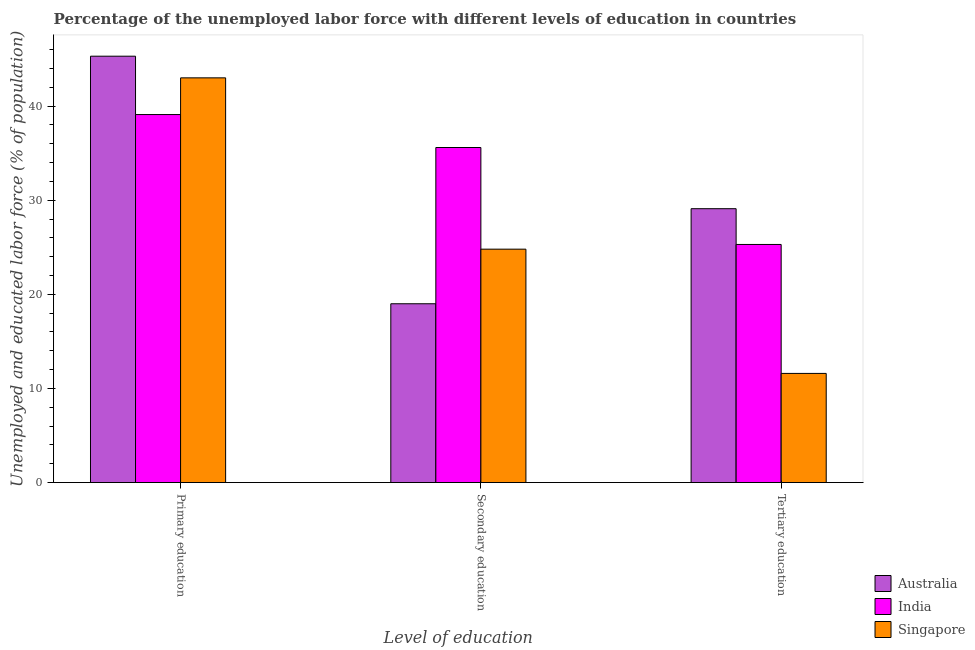How many groups of bars are there?
Provide a short and direct response. 3. Are the number of bars on each tick of the X-axis equal?
Ensure brevity in your answer.  Yes. How many bars are there on the 2nd tick from the right?
Provide a short and direct response. 3. What is the label of the 3rd group of bars from the left?
Provide a short and direct response. Tertiary education. What is the percentage of labor force who received tertiary education in Australia?
Your response must be concise. 29.1. Across all countries, what is the maximum percentage of labor force who received secondary education?
Ensure brevity in your answer.  35.6. Across all countries, what is the minimum percentage of labor force who received secondary education?
Your answer should be very brief. 19. What is the total percentage of labor force who received secondary education in the graph?
Your response must be concise. 79.4. What is the difference between the percentage of labor force who received primary education in Singapore and that in India?
Provide a short and direct response. 3.9. What is the difference between the percentage of labor force who received secondary education in Australia and the percentage of labor force who received primary education in Singapore?
Give a very brief answer. -24. What is the average percentage of labor force who received secondary education per country?
Give a very brief answer. 26.47. What is the difference between the percentage of labor force who received tertiary education and percentage of labor force who received secondary education in India?
Your response must be concise. -10.3. In how many countries, is the percentage of labor force who received secondary education greater than 26 %?
Offer a very short reply. 1. What is the ratio of the percentage of labor force who received tertiary education in Australia to that in India?
Your answer should be very brief. 1.15. What is the difference between the highest and the second highest percentage of labor force who received tertiary education?
Your response must be concise. 3.8. What is the difference between the highest and the lowest percentage of labor force who received secondary education?
Offer a very short reply. 16.6. What does the 1st bar from the left in Secondary education represents?
Ensure brevity in your answer.  Australia. What is the difference between two consecutive major ticks on the Y-axis?
Your response must be concise. 10. Are the values on the major ticks of Y-axis written in scientific E-notation?
Provide a succinct answer. No. Does the graph contain grids?
Your answer should be very brief. No. Where does the legend appear in the graph?
Ensure brevity in your answer.  Bottom right. What is the title of the graph?
Keep it short and to the point. Percentage of the unemployed labor force with different levels of education in countries. Does "Tajikistan" appear as one of the legend labels in the graph?
Keep it short and to the point. No. What is the label or title of the X-axis?
Your response must be concise. Level of education. What is the label or title of the Y-axis?
Your answer should be compact. Unemployed and educated labor force (% of population). What is the Unemployed and educated labor force (% of population) of Australia in Primary education?
Provide a succinct answer. 45.3. What is the Unemployed and educated labor force (% of population) of India in Primary education?
Your response must be concise. 39.1. What is the Unemployed and educated labor force (% of population) in Singapore in Primary education?
Your answer should be compact. 43. What is the Unemployed and educated labor force (% of population) in India in Secondary education?
Ensure brevity in your answer.  35.6. What is the Unemployed and educated labor force (% of population) of Singapore in Secondary education?
Your answer should be very brief. 24.8. What is the Unemployed and educated labor force (% of population) in Australia in Tertiary education?
Your response must be concise. 29.1. What is the Unemployed and educated labor force (% of population) of India in Tertiary education?
Offer a very short reply. 25.3. What is the Unemployed and educated labor force (% of population) of Singapore in Tertiary education?
Make the answer very short. 11.6. Across all Level of education, what is the maximum Unemployed and educated labor force (% of population) in Australia?
Make the answer very short. 45.3. Across all Level of education, what is the maximum Unemployed and educated labor force (% of population) of India?
Offer a terse response. 39.1. Across all Level of education, what is the minimum Unemployed and educated labor force (% of population) of Australia?
Give a very brief answer. 19. Across all Level of education, what is the minimum Unemployed and educated labor force (% of population) in India?
Offer a very short reply. 25.3. Across all Level of education, what is the minimum Unemployed and educated labor force (% of population) in Singapore?
Your answer should be compact. 11.6. What is the total Unemployed and educated labor force (% of population) in Australia in the graph?
Your response must be concise. 93.4. What is the total Unemployed and educated labor force (% of population) in India in the graph?
Give a very brief answer. 100. What is the total Unemployed and educated labor force (% of population) of Singapore in the graph?
Ensure brevity in your answer.  79.4. What is the difference between the Unemployed and educated labor force (% of population) of Australia in Primary education and that in Secondary education?
Give a very brief answer. 26.3. What is the difference between the Unemployed and educated labor force (% of population) in Singapore in Primary education and that in Secondary education?
Provide a short and direct response. 18.2. What is the difference between the Unemployed and educated labor force (% of population) of Singapore in Primary education and that in Tertiary education?
Offer a very short reply. 31.4. What is the difference between the Unemployed and educated labor force (% of population) of Australia in Secondary education and that in Tertiary education?
Provide a short and direct response. -10.1. What is the difference between the Unemployed and educated labor force (% of population) in Singapore in Secondary education and that in Tertiary education?
Make the answer very short. 13.2. What is the difference between the Unemployed and educated labor force (% of population) of Australia in Primary education and the Unemployed and educated labor force (% of population) of India in Tertiary education?
Ensure brevity in your answer.  20. What is the difference between the Unemployed and educated labor force (% of population) in Australia in Primary education and the Unemployed and educated labor force (% of population) in Singapore in Tertiary education?
Your answer should be very brief. 33.7. What is the difference between the Unemployed and educated labor force (% of population) of India in Primary education and the Unemployed and educated labor force (% of population) of Singapore in Tertiary education?
Provide a short and direct response. 27.5. What is the average Unemployed and educated labor force (% of population) of Australia per Level of education?
Offer a very short reply. 31.13. What is the average Unemployed and educated labor force (% of population) in India per Level of education?
Offer a terse response. 33.33. What is the average Unemployed and educated labor force (% of population) in Singapore per Level of education?
Your answer should be very brief. 26.47. What is the difference between the Unemployed and educated labor force (% of population) in Australia and Unemployed and educated labor force (% of population) in India in Secondary education?
Provide a succinct answer. -16.6. What is the difference between the Unemployed and educated labor force (% of population) of Australia and Unemployed and educated labor force (% of population) of Singapore in Secondary education?
Give a very brief answer. -5.8. What is the difference between the Unemployed and educated labor force (% of population) of India and Unemployed and educated labor force (% of population) of Singapore in Secondary education?
Give a very brief answer. 10.8. What is the difference between the Unemployed and educated labor force (% of population) of Australia and Unemployed and educated labor force (% of population) of India in Tertiary education?
Your response must be concise. 3.8. What is the ratio of the Unemployed and educated labor force (% of population) of Australia in Primary education to that in Secondary education?
Offer a terse response. 2.38. What is the ratio of the Unemployed and educated labor force (% of population) in India in Primary education to that in Secondary education?
Provide a short and direct response. 1.1. What is the ratio of the Unemployed and educated labor force (% of population) in Singapore in Primary education to that in Secondary education?
Keep it short and to the point. 1.73. What is the ratio of the Unemployed and educated labor force (% of population) of Australia in Primary education to that in Tertiary education?
Your response must be concise. 1.56. What is the ratio of the Unemployed and educated labor force (% of population) of India in Primary education to that in Tertiary education?
Give a very brief answer. 1.55. What is the ratio of the Unemployed and educated labor force (% of population) of Singapore in Primary education to that in Tertiary education?
Offer a terse response. 3.71. What is the ratio of the Unemployed and educated labor force (% of population) of Australia in Secondary education to that in Tertiary education?
Ensure brevity in your answer.  0.65. What is the ratio of the Unemployed and educated labor force (% of population) of India in Secondary education to that in Tertiary education?
Offer a very short reply. 1.41. What is the ratio of the Unemployed and educated labor force (% of population) in Singapore in Secondary education to that in Tertiary education?
Keep it short and to the point. 2.14. What is the difference between the highest and the second highest Unemployed and educated labor force (% of population) of Australia?
Keep it short and to the point. 16.2. What is the difference between the highest and the second highest Unemployed and educated labor force (% of population) in India?
Keep it short and to the point. 3.5. What is the difference between the highest and the lowest Unemployed and educated labor force (% of population) in Australia?
Offer a very short reply. 26.3. What is the difference between the highest and the lowest Unemployed and educated labor force (% of population) of India?
Your answer should be very brief. 13.8. What is the difference between the highest and the lowest Unemployed and educated labor force (% of population) of Singapore?
Offer a terse response. 31.4. 